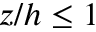Convert formula to latex. <formula><loc_0><loc_0><loc_500><loc_500>z / h \leq 1</formula> 